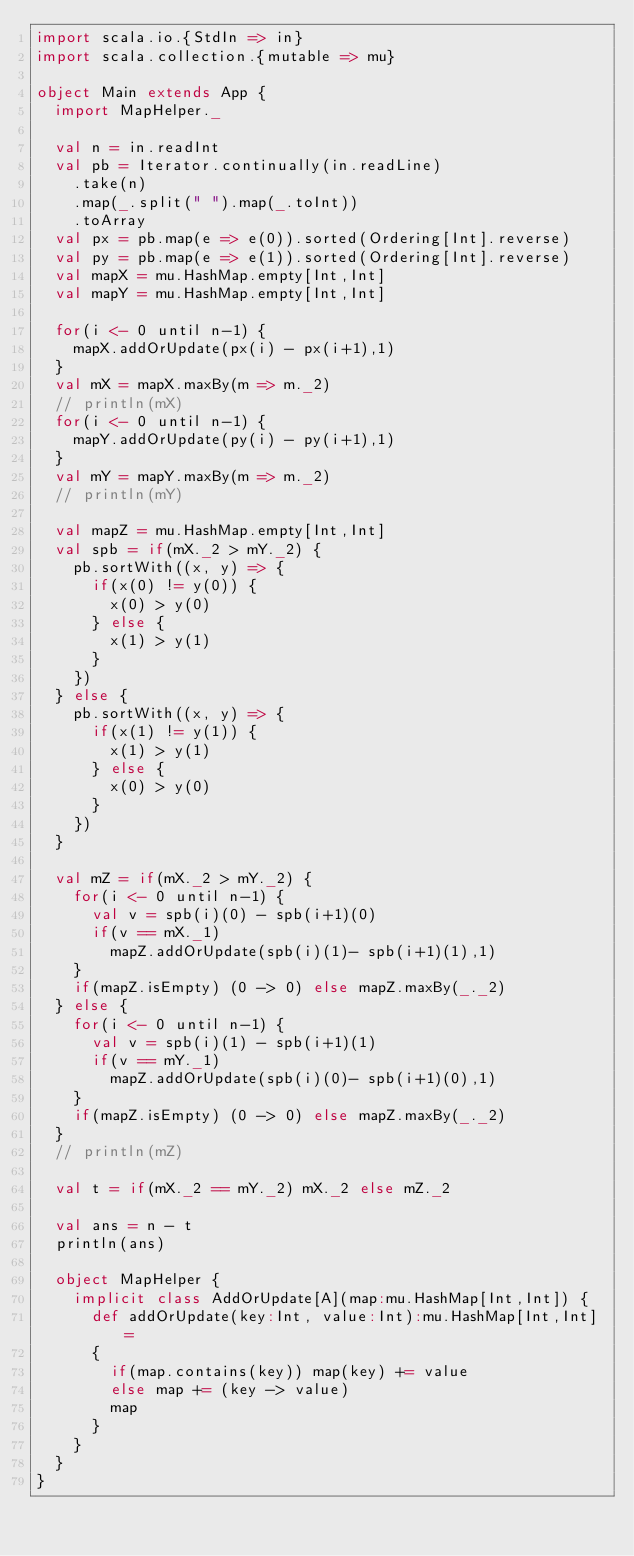<code> <loc_0><loc_0><loc_500><loc_500><_Scala_>import scala.io.{StdIn => in}
import scala.collection.{mutable => mu}

object Main extends App {
  import MapHelper._

  val n = in.readInt
  val pb = Iterator.continually(in.readLine)
    .take(n)
    .map(_.split(" ").map(_.toInt))
    .toArray
  val px = pb.map(e => e(0)).sorted(Ordering[Int].reverse)
  val py = pb.map(e => e(1)).sorted(Ordering[Int].reverse)
  val mapX = mu.HashMap.empty[Int,Int]
  val mapY = mu.HashMap.empty[Int,Int]

  for(i <- 0 until n-1) {
    mapX.addOrUpdate(px(i) - px(i+1),1)
  }
  val mX = mapX.maxBy(m => m._2)
  // println(mX)
  for(i <- 0 until n-1) {
    mapY.addOrUpdate(py(i) - py(i+1),1)
  }
  val mY = mapY.maxBy(m => m._2)
  // println(mY)

  val mapZ = mu.HashMap.empty[Int,Int]
  val spb = if(mX._2 > mY._2) {
    pb.sortWith((x, y) => {
      if(x(0) != y(0)) {
        x(0) > y(0)
      } else {
        x(1) > y(1)
      }
    })
  } else {
    pb.sortWith((x, y) => {
      if(x(1) != y(1)) {
        x(1) > y(1)
      } else {
        x(0) > y(0)
      }
    })
  }

  val mZ = if(mX._2 > mY._2) {
    for(i <- 0 until n-1) {
      val v = spb(i)(0) - spb(i+1)(0)
      if(v == mX._1)
        mapZ.addOrUpdate(spb(i)(1)- spb(i+1)(1),1)
    }
    if(mapZ.isEmpty) (0 -> 0) else mapZ.maxBy(_._2)
  } else {
    for(i <- 0 until n-1) {
      val v = spb(i)(1) - spb(i+1)(1)
      if(v == mY._1)
        mapZ.addOrUpdate(spb(i)(0)- spb(i+1)(0),1)
    }
    if(mapZ.isEmpty) (0 -> 0) else mapZ.maxBy(_._2)
  }
  // println(mZ)

  val t = if(mX._2 == mY._2) mX._2 else mZ._2

  val ans = n - t
  println(ans)

  object MapHelper {
    implicit class AddOrUpdate[A](map:mu.HashMap[Int,Int]) {
      def addOrUpdate(key:Int, value:Int):mu.HashMap[Int,Int] =
      {
        if(map.contains(key)) map(key) += value
        else map += (key -> value)
        map
      }
    }
  }
}</code> 